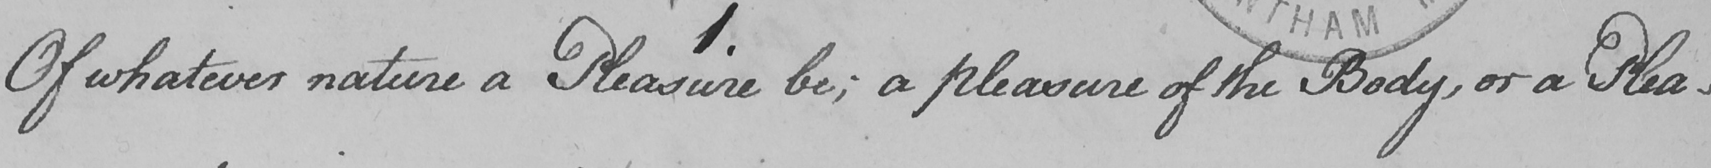Can you tell me what this handwritten text says? 1 . Of whatever nature a Pleasure be ; a pleasure of the Body , or a Plea- 